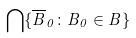Convert formula to latex. <formula><loc_0><loc_0><loc_500><loc_500>\bigcap \{ \overline { B } _ { 0 } \colon B _ { 0 } \in B \}</formula> 